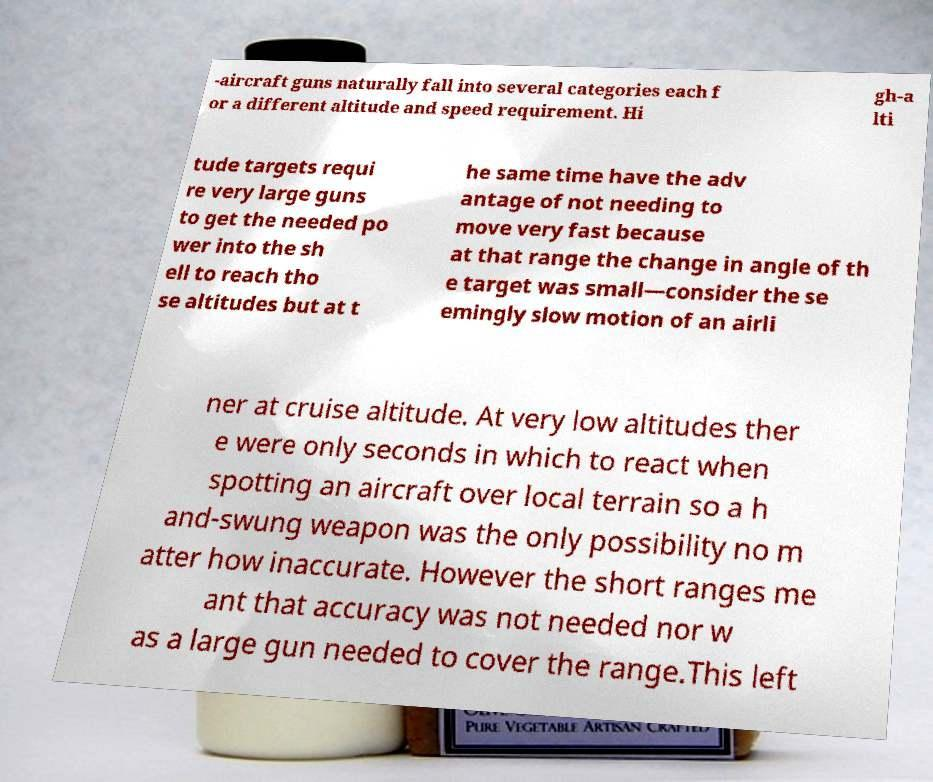Please read and relay the text visible in this image. What does it say? -aircraft guns naturally fall into several categories each f or a different altitude and speed requirement. Hi gh-a lti tude targets requi re very large guns to get the needed po wer into the sh ell to reach tho se altitudes but at t he same time have the adv antage of not needing to move very fast because at that range the change in angle of th e target was small—consider the se emingly slow motion of an airli ner at cruise altitude. At very low altitudes ther e were only seconds in which to react when spotting an aircraft over local terrain so a h and-swung weapon was the only possibility no m atter how inaccurate. However the short ranges me ant that accuracy was not needed nor w as a large gun needed to cover the range.This left 